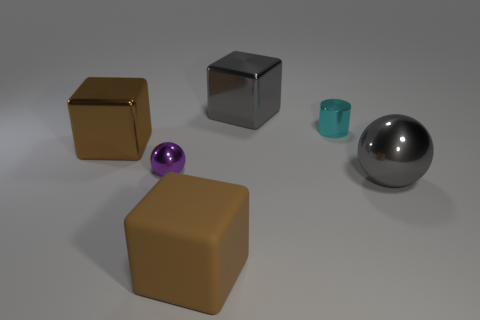What materials do the objects in the image appear to be made of? The objects in the image appear to be made of various materials: the large and small cubes have a matte surface resembling rubber or plastic, the cylinder looks to be ceramic or plastic with its slight shine, and the two spheres exhibit reflective properties, like polished metal or glass.  Can you tell me which of these objects is the smallest? The smallest object appears to be the purple sphere, considering its relative size compared to the other objects placed near it. 